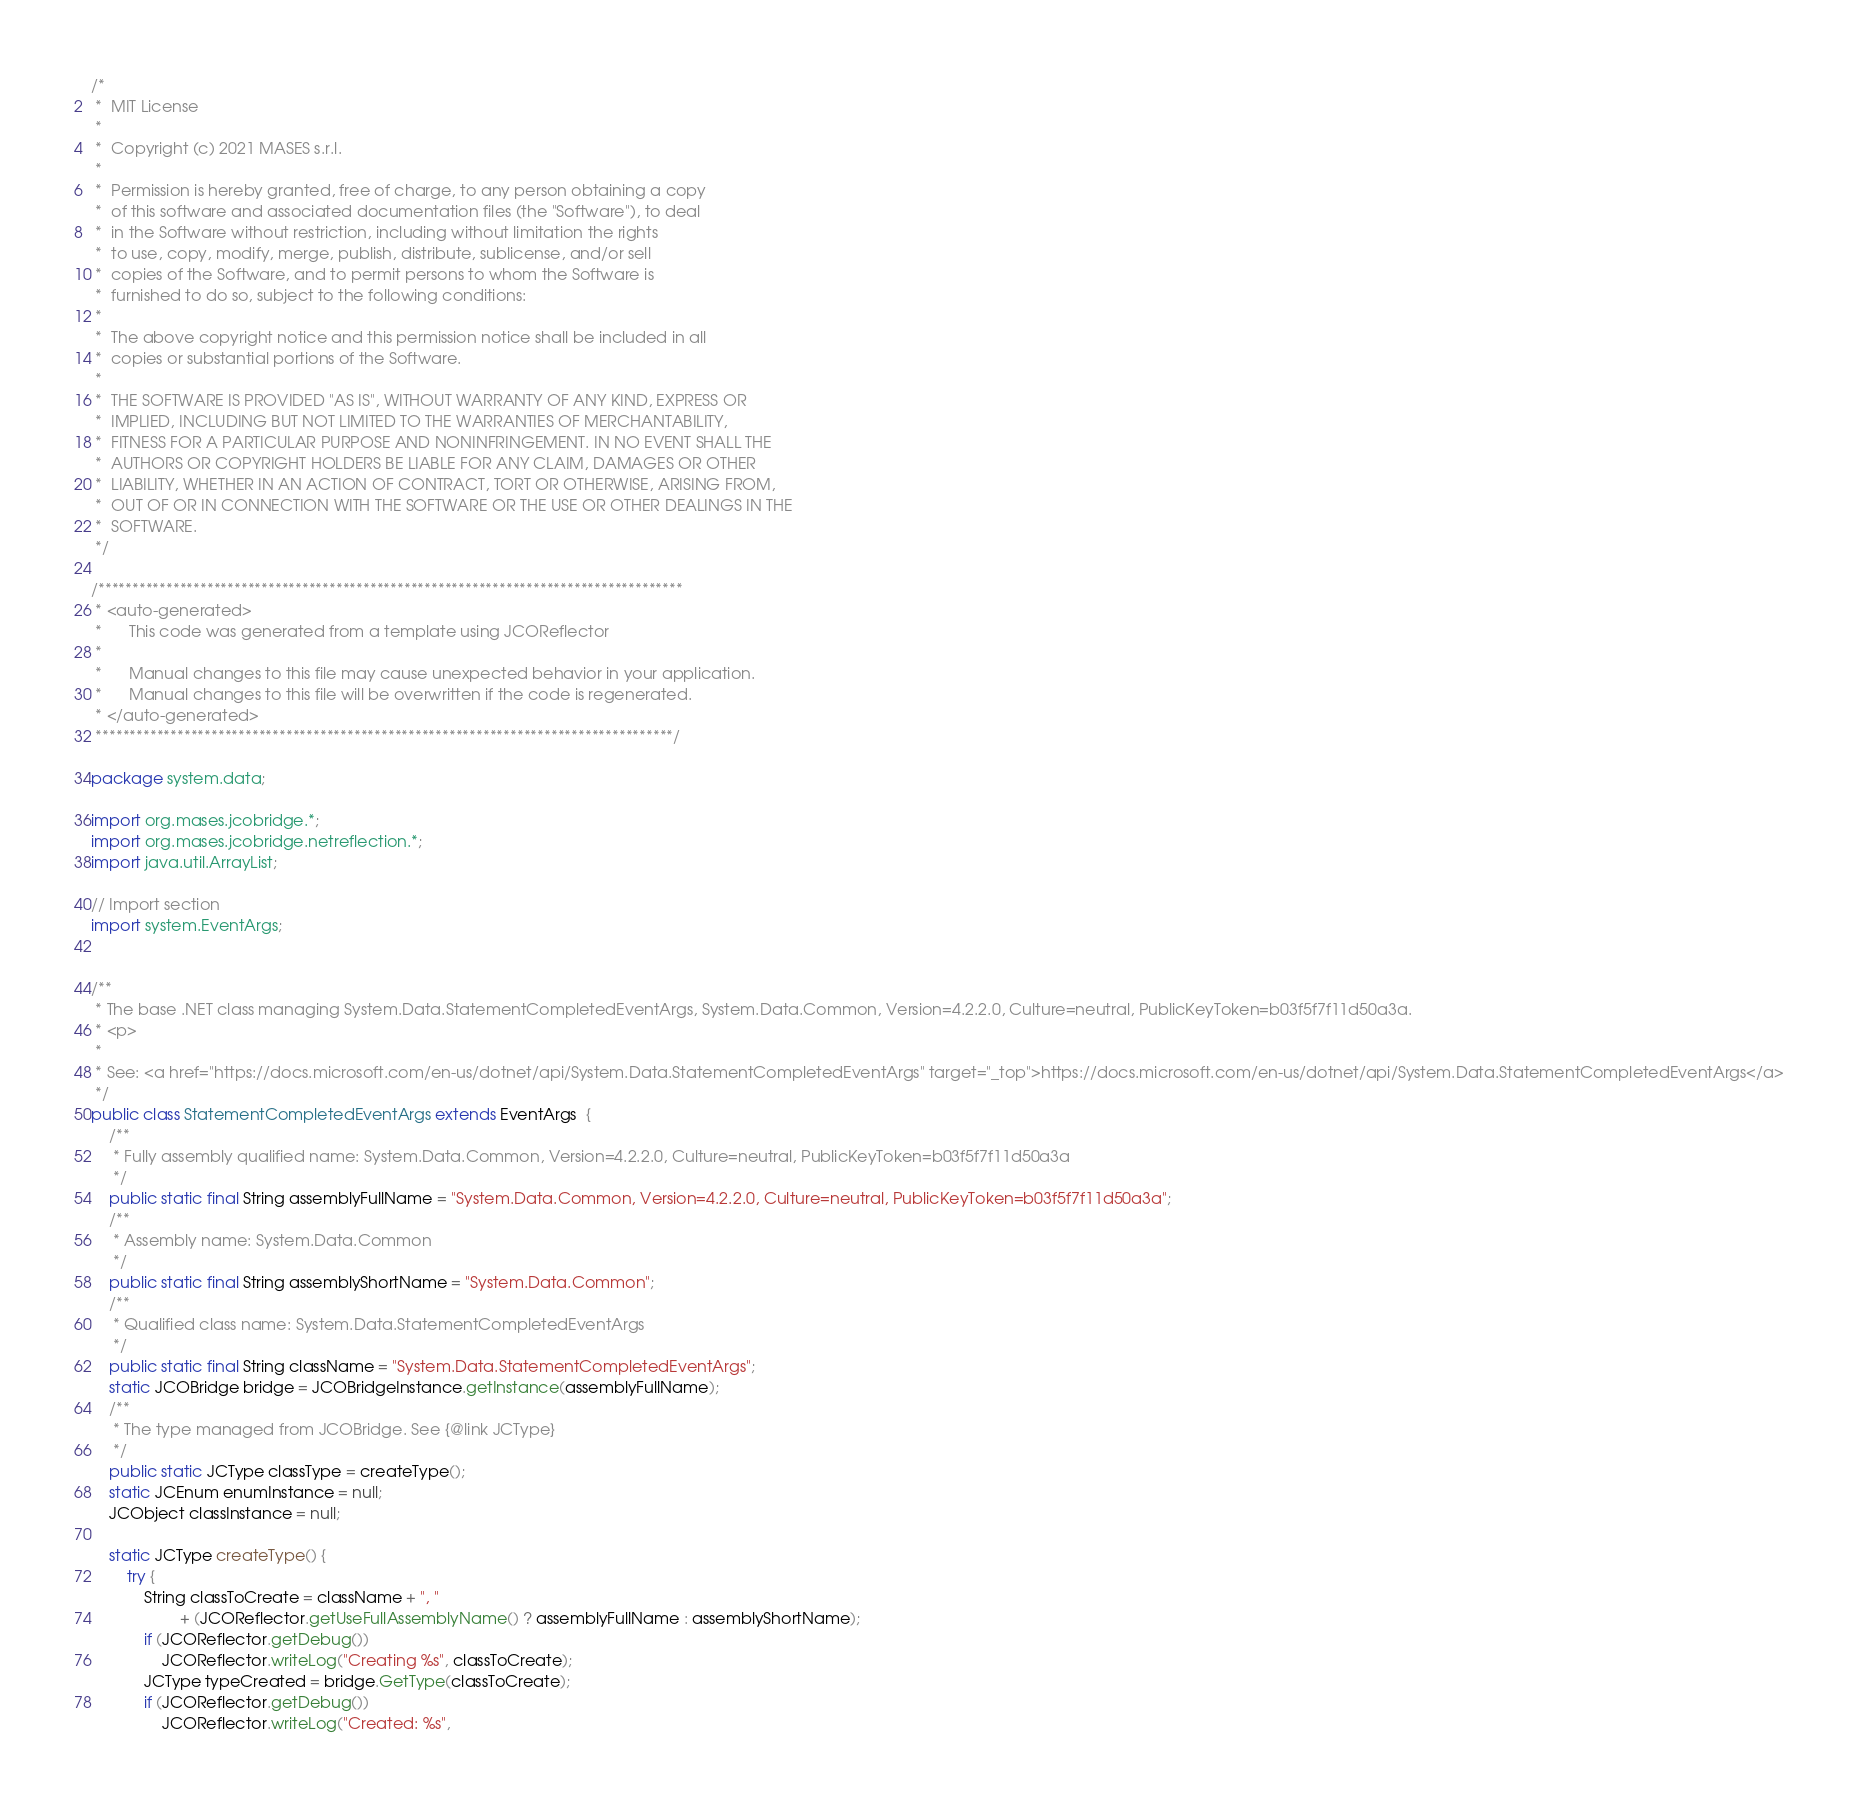<code> <loc_0><loc_0><loc_500><loc_500><_Java_>/*
 *  MIT License
 *
 *  Copyright (c) 2021 MASES s.r.l.
 *
 *  Permission is hereby granted, free of charge, to any person obtaining a copy
 *  of this software and associated documentation files (the "Software"), to deal
 *  in the Software without restriction, including without limitation the rights
 *  to use, copy, modify, merge, publish, distribute, sublicense, and/or sell
 *  copies of the Software, and to permit persons to whom the Software is
 *  furnished to do so, subject to the following conditions:
 *
 *  The above copyright notice and this permission notice shall be included in all
 *  copies or substantial portions of the Software.
 *
 *  THE SOFTWARE IS PROVIDED "AS IS", WITHOUT WARRANTY OF ANY KIND, EXPRESS OR
 *  IMPLIED, INCLUDING BUT NOT LIMITED TO THE WARRANTIES OF MERCHANTABILITY,
 *  FITNESS FOR A PARTICULAR PURPOSE AND NONINFRINGEMENT. IN NO EVENT SHALL THE
 *  AUTHORS OR COPYRIGHT HOLDERS BE LIABLE FOR ANY CLAIM, DAMAGES OR OTHER
 *  LIABILITY, WHETHER IN AN ACTION OF CONTRACT, TORT OR OTHERWISE, ARISING FROM,
 *  OUT OF OR IN CONNECTION WITH THE SOFTWARE OR THE USE OR OTHER DEALINGS IN THE
 *  SOFTWARE.
 */

/**************************************************************************************
 * <auto-generated>
 *      This code was generated from a template using JCOReflector
 * 
 *      Manual changes to this file may cause unexpected behavior in your application.
 *      Manual changes to this file will be overwritten if the code is regenerated.
 * </auto-generated>
 *************************************************************************************/

package system.data;

import org.mases.jcobridge.*;
import org.mases.jcobridge.netreflection.*;
import java.util.ArrayList;

// Import section
import system.EventArgs;


/**
 * The base .NET class managing System.Data.StatementCompletedEventArgs, System.Data.Common, Version=4.2.2.0, Culture=neutral, PublicKeyToken=b03f5f7f11d50a3a.
 * <p>
 * 
 * See: <a href="https://docs.microsoft.com/en-us/dotnet/api/System.Data.StatementCompletedEventArgs" target="_top">https://docs.microsoft.com/en-us/dotnet/api/System.Data.StatementCompletedEventArgs</a>
 */
public class StatementCompletedEventArgs extends EventArgs  {
    /**
     * Fully assembly qualified name: System.Data.Common, Version=4.2.2.0, Culture=neutral, PublicKeyToken=b03f5f7f11d50a3a
     */
    public static final String assemblyFullName = "System.Data.Common, Version=4.2.2.0, Culture=neutral, PublicKeyToken=b03f5f7f11d50a3a";
    /**
     * Assembly name: System.Data.Common
     */
    public static final String assemblyShortName = "System.Data.Common";
    /**
     * Qualified class name: System.Data.StatementCompletedEventArgs
     */
    public static final String className = "System.Data.StatementCompletedEventArgs";
    static JCOBridge bridge = JCOBridgeInstance.getInstance(assemblyFullName);
    /**
     * The type managed from JCOBridge. See {@link JCType}
     */
    public static JCType classType = createType();
    static JCEnum enumInstance = null;
    JCObject classInstance = null;

    static JCType createType() {
        try {
            String classToCreate = className + ", "
                    + (JCOReflector.getUseFullAssemblyName() ? assemblyFullName : assemblyShortName);
            if (JCOReflector.getDebug())
                JCOReflector.writeLog("Creating %s", classToCreate);
            JCType typeCreated = bridge.GetType(classToCreate);
            if (JCOReflector.getDebug())
                JCOReflector.writeLog("Created: %s",</code> 